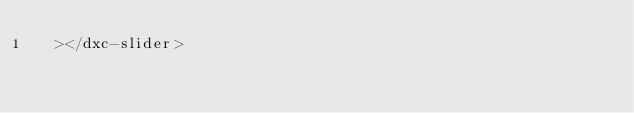<code> <loc_0><loc_0><loc_500><loc_500><_HTML_>  ></dxc-slider>
</code> 